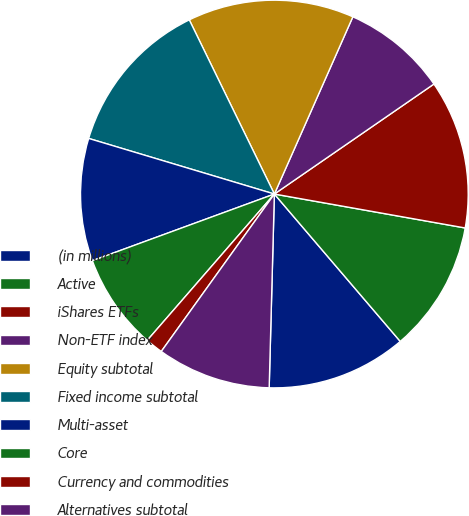Convert chart to OTSL. <chart><loc_0><loc_0><loc_500><loc_500><pie_chart><fcel>(in millions)<fcel>Active<fcel>iShares ETFs<fcel>Non-ETF index<fcel>Equity subtotal<fcel>Fixed income subtotal<fcel>Multi-asset<fcel>Core<fcel>Currency and commodities<fcel>Alternatives subtotal<nl><fcel>11.68%<fcel>10.95%<fcel>12.41%<fcel>8.76%<fcel>13.87%<fcel>13.14%<fcel>10.22%<fcel>8.03%<fcel>1.47%<fcel>9.49%<nl></chart> 